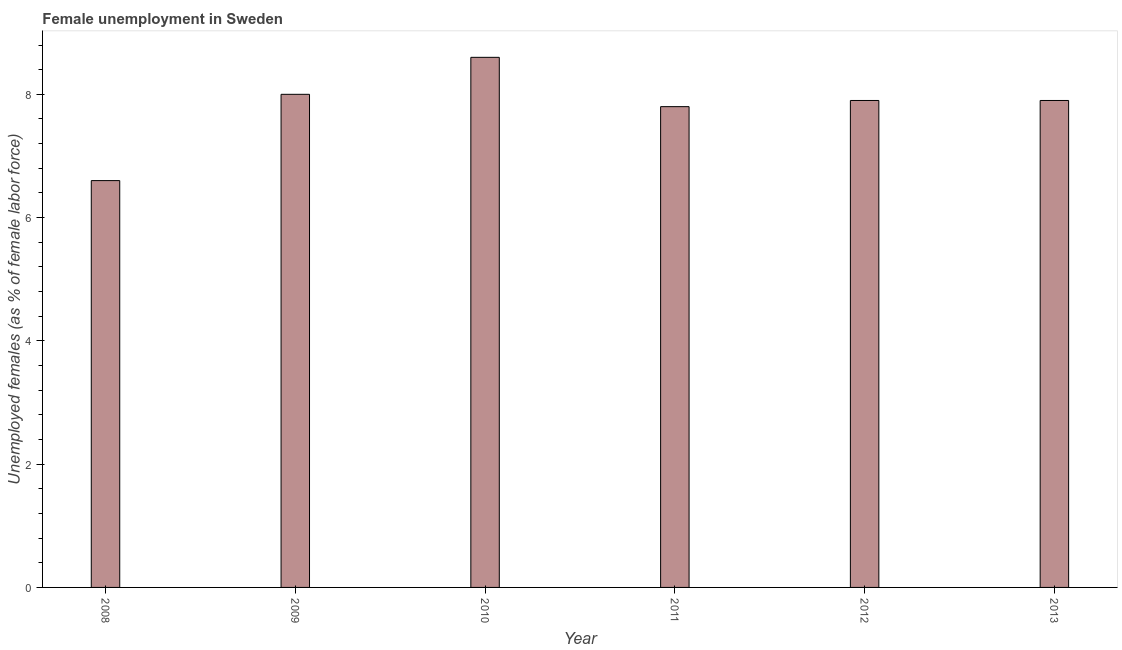Does the graph contain grids?
Your answer should be compact. No. What is the title of the graph?
Keep it short and to the point. Female unemployment in Sweden. What is the label or title of the X-axis?
Your answer should be compact. Year. What is the label or title of the Y-axis?
Provide a succinct answer. Unemployed females (as % of female labor force). What is the unemployed females population in 2008?
Give a very brief answer. 6.6. Across all years, what is the maximum unemployed females population?
Ensure brevity in your answer.  8.6. Across all years, what is the minimum unemployed females population?
Ensure brevity in your answer.  6.6. In which year was the unemployed females population maximum?
Your answer should be compact. 2010. In which year was the unemployed females population minimum?
Your answer should be very brief. 2008. What is the sum of the unemployed females population?
Your answer should be compact. 46.8. What is the average unemployed females population per year?
Provide a short and direct response. 7.8. What is the median unemployed females population?
Provide a short and direct response. 7.9. Do a majority of the years between 2010 and 2013 (inclusive) have unemployed females population greater than 3.6 %?
Make the answer very short. Yes. What is the ratio of the unemployed females population in 2008 to that in 2012?
Offer a terse response. 0.83. Is the sum of the unemployed females population in 2009 and 2011 greater than the maximum unemployed females population across all years?
Your response must be concise. Yes. What is the difference between the highest and the lowest unemployed females population?
Keep it short and to the point. 2. In how many years, is the unemployed females population greater than the average unemployed females population taken over all years?
Your answer should be very brief. 5. What is the difference between two consecutive major ticks on the Y-axis?
Provide a succinct answer. 2. Are the values on the major ticks of Y-axis written in scientific E-notation?
Your answer should be compact. No. What is the Unemployed females (as % of female labor force) of 2008?
Your answer should be very brief. 6.6. What is the Unemployed females (as % of female labor force) in 2009?
Give a very brief answer. 8. What is the Unemployed females (as % of female labor force) of 2010?
Make the answer very short. 8.6. What is the Unemployed females (as % of female labor force) of 2011?
Provide a succinct answer. 7.8. What is the Unemployed females (as % of female labor force) of 2012?
Offer a very short reply. 7.9. What is the Unemployed females (as % of female labor force) in 2013?
Offer a terse response. 7.9. What is the difference between the Unemployed females (as % of female labor force) in 2009 and 2010?
Your answer should be very brief. -0.6. What is the difference between the Unemployed females (as % of female labor force) in 2009 and 2011?
Keep it short and to the point. 0.2. What is the difference between the Unemployed females (as % of female labor force) in 2009 and 2012?
Keep it short and to the point. 0.1. What is the difference between the Unemployed females (as % of female labor force) in 2010 and 2011?
Offer a very short reply. 0.8. What is the difference between the Unemployed females (as % of female labor force) in 2010 and 2012?
Offer a very short reply. 0.7. What is the difference between the Unemployed females (as % of female labor force) in 2010 and 2013?
Your answer should be compact. 0.7. What is the difference between the Unemployed females (as % of female labor force) in 2011 and 2012?
Your answer should be very brief. -0.1. What is the difference between the Unemployed females (as % of female labor force) in 2012 and 2013?
Offer a very short reply. 0. What is the ratio of the Unemployed females (as % of female labor force) in 2008 to that in 2009?
Ensure brevity in your answer.  0.82. What is the ratio of the Unemployed females (as % of female labor force) in 2008 to that in 2010?
Your answer should be very brief. 0.77. What is the ratio of the Unemployed females (as % of female labor force) in 2008 to that in 2011?
Your answer should be compact. 0.85. What is the ratio of the Unemployed females (as % of female labor force) in 2008 to that in 2012?
Keep it short and to the point. 0.83. What is the ratio of the Unemployed females (as % of female labor force) in 2008 to that in 2013?
Offer a very short reply. 0.83. What is the ratio of the Unemployed females (as % of female labor force) in 2009 to that in 2010?
Give a very brief answer. 0.93. What is the ratio of the Unemployed females (as % of female labor force) in 2009 to that in 2012?
Ensure brevity in your answer.  1.01. What is the ratio of the Unemployed females (as % of female labor force) in 2010 to that in 2011?
Give a very brief answer. 1.1. What is the ratio of the Unemployed females (as % of female labor force) in 2010 to that in 2012?
Your answer should be very brief. 1.09. What is the ratio of the Unemployed females (as % of female labor force) in 2010 to that in 2013?
Provide a short and direct response. 1.09. What is the ratio of the Unemployed females (as % of female labor force) in 2011 to that in 2012?
Keep it short and to the point. 0.99. What is the ratio of the Unemployed females (as % of female labor force) in 2011 to that in 2013?
Make the answer very short. 0.99. 